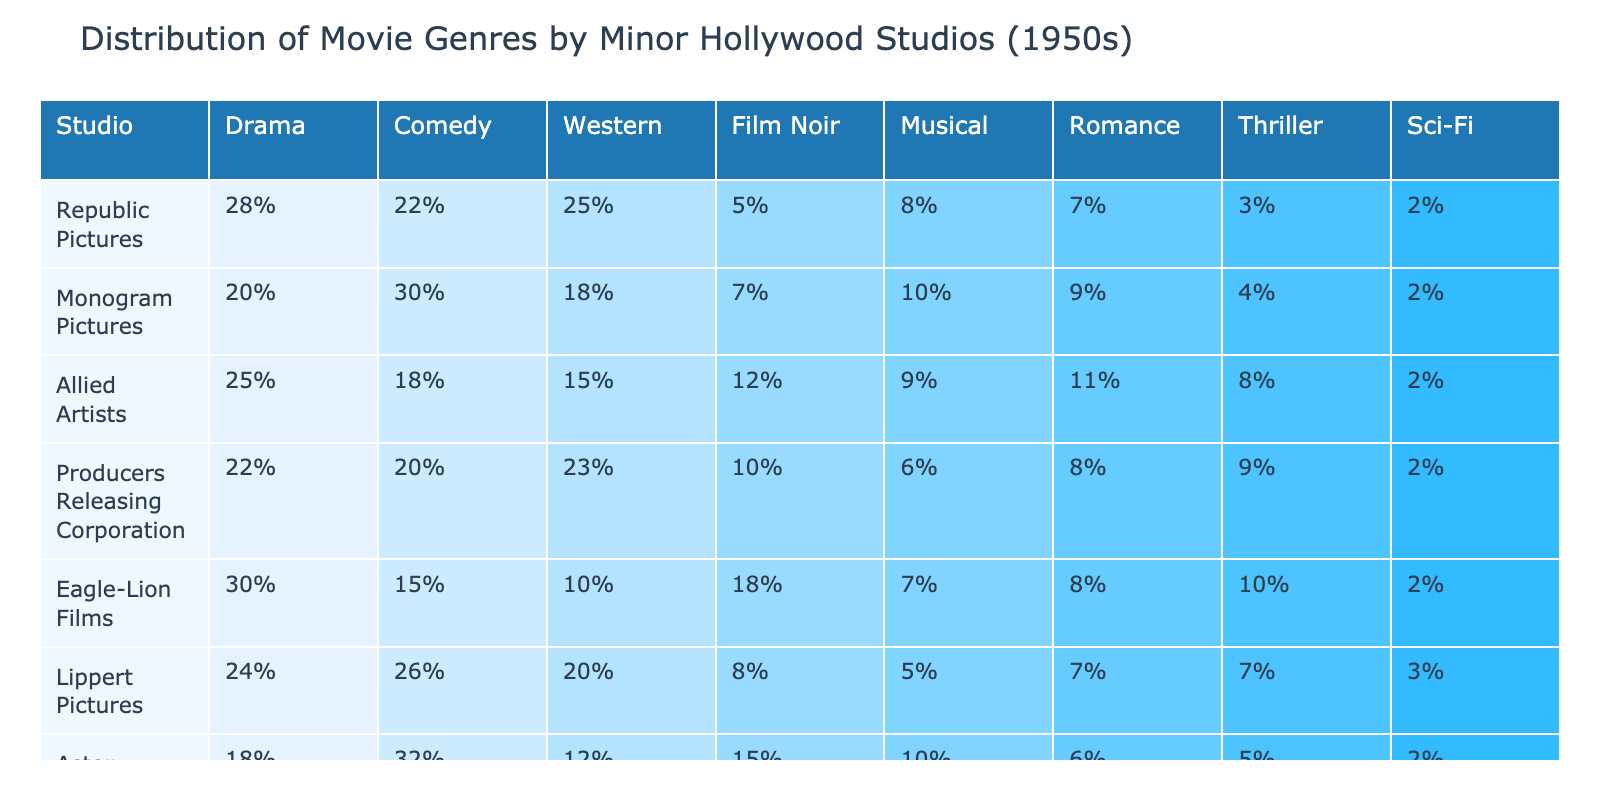What percentage of films produced by Republic Pictures are in the Thriller genre? Looking at the row for Republic Pictures, the percentage listed under the Thriller column is 3%.
Answer: 3% Which studio produced the highest percentage of Western films? By comparing the percentages of Western films across all studios, Republic Pictures has the highest percentage at 25%.
Answer: Republic Pictures What is the average percentage of Musical films produced by all studios listed? To find the average, add the percentages of Musical films from all studios (8 + 10 + 9 + 6 + 7 + 5 + 10 + 8) = 63, and divide by the number of studios (8). So, 63/8 = 7.875%.
Answer: 7.875% Did Astor Pictures produce a higher percentage of Comedy or Sci-Fi films? Astor Pictures produced 32% of Comedy films and 2% of Sci-Fi films. Since 32% is greater than 2%, the answer is that Astor Pictures produced a higher percentage of Comedy films.
Answer: Yes What is the difference in percentage of Drama films produced by Eagle-Lion Films and Monogram Pictures? Eagle-Lion Films produced 30% of Drama films and Monogram Pictures produced 20%. The difference is calculated as 30% - 20% = 10%.
Answer: 10% Which studio produced the lowest percentage of Film Noir films? Upon reviewing the Film Noir column, it is clear that Astor Pictures has the lowest percentage at 5%.
Answer: Astor Pictures If we consider only the Thriller genre, which studio produced more films: Allied Artists or Producers Releasing Corporation? Allied Artists produced 8% of Thriller films while Producers Releasing Corporation produced 9%. Since 9% is greater than 8%, Producers Releasing Corporation produced more Thriller films.
Answer: Producers Releasing Corporation What genre accounts for the majority of film production for Lippert Pictures? Lippert Pictures produced the highest percentage in the Comedy genre with 26%, which is more than any other genre.
Answer: Comedy Which studio has the most balanced distribution across all genres based on the percentage values? By reviewing the distributions, Astor Pictures has the most balanced values with no extreme highs or lows, with percentages mainly ranging around 10-32%.
Answer: Astor Pictures Which two studios combined produced the least percentage of Sci-Fi films? The Sci-Fi percentages for Republic Pictures (2%) and Monogram Pictures (2%) add up to 4%, the least among all studios.
Answer: Republic Pictures and Monogram Pictures 